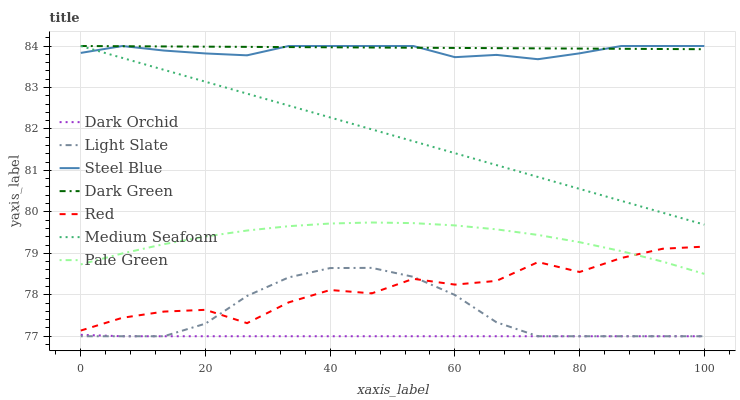Does Dark Orchid have the minimum area under the curve?
Answer yes or no. Yes. Does Dark Green have the maximum area under the curve?
Answer yes or no. Yes. Does Steel Blue have the minimum area under the curve?
Answer yes or no. No. Does Steel Blue have the maximum area under the curve?
Answer yes or no. No. Is Medium Seafoam the smoothest?
Answer yes or no. Yes. Is Red the roughest?
Answer yes or no. Yes. Is Steel Blue the smoothest?
Answer yes or no. No. Is Steel Blue the roughest?
Answer yes or no. No. Does Steel Blue have the lowest value?
Answer yes or no. No. Does Dark Orchid have the highest value?
Answer yes or no. No. Is Dark Orchid less than Dark Green?
Answer yes or no. Yes. Is Dark Green greater than Red?
Answer yes or no. Yes. Does Dark Orchid intersect Dark Green?
Answer yes or no. No. 